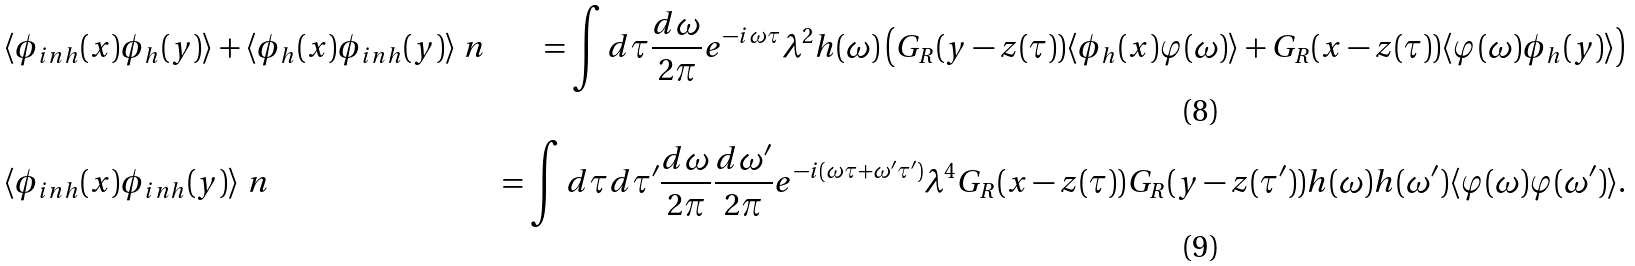Convert formula to latex. <formula><loc_0><loc_0><loc_500><loc_500>& \langle \phi _ { i n h } ( x ) \phi _ { h } ( y ) \rangle + \langle \phi _ { h } ( x ) \phi _ { i n h } ( y ) \rangle \ n & = \int d \tau \frac { d \omega } { 2 \pi } e ^ { - i \omega \tau } \lambda ^ { 2 } h ( \omega ) \left ( G _ { R } ( y - z ( \tau ) ) \langle \phi _ { h } ( x ) \varphi ( \omega ) \rangle + G _ { R } ( x - z ( \tau ) ) \langle \varphi ( \omega ) \phi _ { h } ( y ) \rangle \right ) \\ & \langle \phi _ { i n h } ( x ) \phi _ { i n h } ( y ) \rangle \ n & = \int d \tau d \tau ^ { \prime } \frac { d \omega } { 2 \pi } \frac { d \omega ^ { \prime } } { 2 \pi } e ^ { - i ( \omega \tau + \omega ^ { \prime } \tau ^ { \prime } ) } \lambda ^ { 4 } G _ { R } ( x - z ( \tau ) ) G _ { R } ( y - z ( \tau ^ { \prime } ) ) h ( \omega ) h ( \omega ^ { \prime } ) \langle \varphi ( \omega ) \varphi ( \omega ^ { \prime } ) \rangle .</formula> 